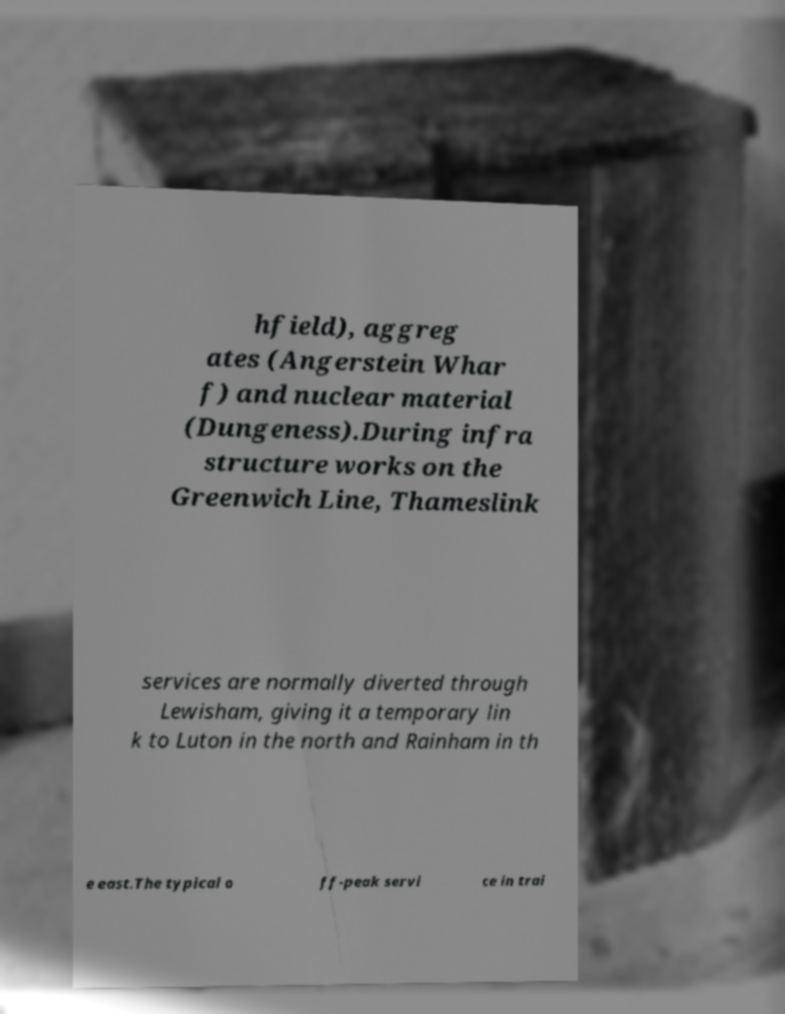Could you extract and type out the text from this image? hfield), aggreg ates (Angerstein Whar f) and nuclear material (Dungeness).During infra structure works on the Greenwich Line, Thameslink services are normally diverted through Lewisham, giving it a temporary lin k to Luton in the north and Rainham in th e east.The typical o ff-peak servi ce in trai 